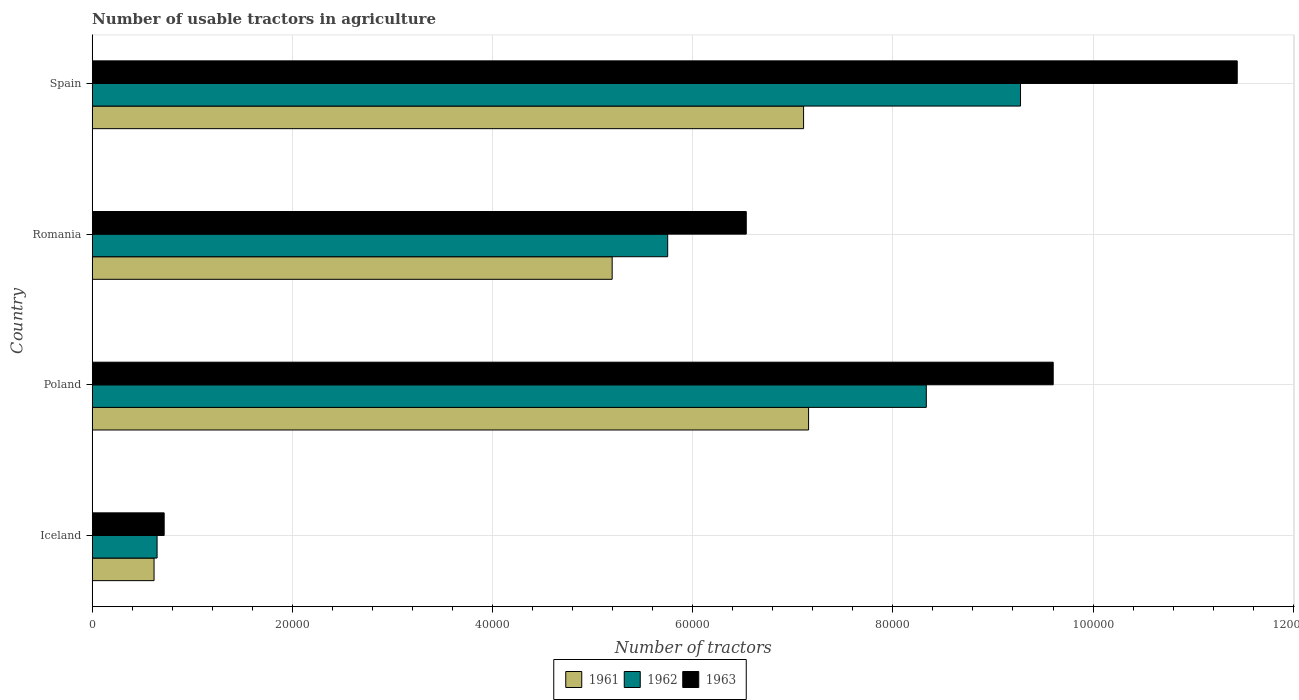How many groups of bars are there?
Keep it short and to the point. 4. Are the number of bars per tick equal to the number of legend labels?
Keep it short and to the point. Yes. What is the label of the 2nd group of bars from the top?
Ensure brevity in your answer.  Romania. What is the number of usable tractors in agriculture in 1961 in Poland?
Provide a short and direct response. 7.16e+04. Across all countries, what is the maximum number of usable tractors in agriculture in 1962?
Your answer should be very brief. 9.28e+04. Across all countries, what is the minimum number of usable tractors in agriculture in 1963?
Offer a terse response. 7187. In which country was the number of usable tractors in agriculture in 1962 minimum?
Offer a very short reply. Iceland. What is the total number of usable tractors in agriculture in 1962 in the graph?
Your answer should be compact. 2.40e+05. What is the difference between the number of usable tractors in agriculture in 1961 in Iceland and that in Spain?
Ensure brevity in your answer.  -6.49e+04. What is the difference between the number of usable tractors in agriculture in 1962 in Romania and the number of usable tractors in agriculture in 1963 in Spain?
Your answer should be very brief. -5.69e+04. What is the average number of usable tractors in agriculture in 1963 per country?
Ensure brevity in your answer.  7.07e+04. What is the difference between the number of usable tractors in agriculture in 1962 and number of usable tractors in agriculture in 1961 in Iceland?
Offer a very short reply. 302. What is the ratio of the number of usable tractors in agriculture in 1963 in Iceland to that in Romania?
Ensure brevity in your answer.  0.11. What is the difference between the highest and the lowest number of usable tractors in agriculture in 1963?
Your answer should be very brief. 1.07e+05. In how many countries, is the number of usable tractors in agriculture in 1961 greater than the average number of usable tractors in agriculture in 1961 taken over all countries?
Provide a short and direct response. 3. Is the sum of the number of usable tractors in agriculture in 1962 in Iceland and Spain greater than the maximum number of usable tractors in agriculture in 1963 across all countries?
Your answer should be compact. No. What does the 1st bar from the top in Romania represents?
Provide a succinct answer. 1963. Is it the case that in every country, the sum of the number of usable tractors in agriculture in 1963 and number of usable tractors in agriculture in 1962 is greater than the number of usable tractors in agriculture in 1961?
Your answer should be very brief. Yes. What is the difference between two consecutive major ticks on the X-axis?
Offer a very short reply. 2.00e+04. Are the values on the major ticks of X-axis written in scientific E-notation?
Your answer should be very brief. No. Does the graph contain grids?
Ensure brevity in your answer.  Yes. Where does the legend appear in the graph?
Offer a terse response. Bottom center. What is the title of the graph?
Offer a very short reply. Number of usable tractors in agriculture. What is the label or title of the X-axis?
Provide a succinct answer. Number of tractors. What is the Number of tractors in 1961 in Iceland?
Keep it short and to the point. 6177. What is the Number of tractors in 1962 in Iceland?
Ensure brevity in your answer.  6479. What is the Number of tractors in 1963 in Iceland?
Your answer should be very brief. 7187. What is the Number of tractors of 1961 in Poland?
Your answer should be compact. 7.16e+04. What is the Number of tractors in 1962 in Poland?
Give a very brief answer. 8.33e+04. What is the Number of tractors of 1963 in Poland?
Keep it short and to the point. 9.60e+04. What is the Number of tractors in 1961 in Romania?
Your answer should be compact. 5.20e+04. What is the Number of tractors of 1962 in Romania?
Keep it short and to the point. 5.75e+04. What is the Number of tractors of 1963 in Romania?
Your answer should be compact. 6.54e+04. What is the Number of tractors of 1961 in Spain?
Your response must be concise. 7.11e+04. What is the Number of tractors of 1962 in Spain?
Make the answer very short. 9.28e+04. What is the Number of tractors of 1963 in Spain?
Give a very brief answer. 1.14e+05. Across all countries, what is the maximum Number of tractors in 1961?
Offer a very short reply. 7.16e+04. Across all countries, what is the maximum Number of tractors in 1962?
Offer a very short reply. 9.28e+04. Across all countries, what is the maximum Number of tractors of 1963?
Ensure brevity in your answer.  1.14e+05. Across all countries, what is the minimum Number of tractors in 1961?
Keep it short and to the point. 6177. Across all countries, what is the minimum Number of tractors of 1962?
Offer a terse response. 6479. Across all countries, what is the minimum Number of tractors in 1963?
Provide a succinct answer. 7187. What is the total Number of tractors in 1961 in the graph?
Make the answer very short. 2.01e+05. What is the total Number of tractors of 1962 in the graph?
Ensure brevity in your answer.  2.40e+05. What is the total Number of tractors of 1963 in the graph?
Ensure brevity in your answer.  2.83e+05. What is the difference between the Number of tractors of 1961 in Iceland and that in Poland?
Provide a succinct answer. -6.54e+04. What is the difference between the Number of tractors of 1962 in Iceland and that in Poland?
Provide a succinct answer. -7.69e+04. What is the difference between the Number of tractors of 1963 in Iceland and that in Poland?
Offer a very short reply. -8.88e+04. What is the difference between the Number of tractors in 1961 in Iceland and that in Romania?
Make the answer very short. -4.58e+04. What is the difference between the Number of tractors in 1962 in Iceland and that in Romania?
Make the answer very short. -5.10e+04. What is the difference between the Number of tractors of 1963 in Iceland and that in Romania?
Keep it short and to the point. -5.82e+04. What is the difference between the Number of tractors in 1961 in Iceland and that in Spain?
Your answer should be very brief. -6.49e+04. What is the difference between the Number of tractors of 1962 in Iceland and that in Spain?
Your response must be concise. -8.63e+04. What is the difference between the Number of tractors of 1963 in Iceland and that in Spain?
Your response must be concise. -1.07e+05. What is the difference between the Number of tractors in 1961 in Poland and that in Romania?
Offer a very short reply. 1.96e+04. What is the difference between the Number of tractors in 1962 in Poland and that in Romania?
Provide a short and direct response. 2.58e+04. What is the difference between the Number of tractors in 1963 in Poland and that in Romania?
Ensure brevity in your answer.  3.07e+04. What is the difference between the Number of tractors of 1961 in Poland and that in Spain?
Provide a short and direct response. 500. What is the difference between the Number of tractors of 1962 in Poland and that in Spain?
Keep it short and to the point. -9414. What is the difference between the Number of tractors in 1963 in Poland and that in Spain?
Ensure brevity in your answer.  -1.84e+04. What is the difference between the Number of tractors in 1961 in Romania and that in Spain?
Offer a very short reply. -1.91e+04. What is the difference between the Number of tractors in 1962 in Romania and that in Spain?
Make the answer very short. -3.53e+04. What is the difference between the Number of tractors in 1963 in Romania and that in Spain?
Provide a succinct answer. -4.91e+04. What is the difference between the Number of tractors in 1961 in Iceland and the Number of tractors in 1962 in Poland?
Your response must be concise. -7.72e+04. What is the difference between the Number of tractors in 1961 in Iceland and the Number of tractors in 1963 in Poland?
Keep it short and to the point. -8.98e+04. What is the difference between the Number of tractors of 1962 in Iceland and the Number of tractors of 1963 in Poland?
Offer a very short reply. -8.95e+04. What is the difference between the Number of tractors in 1961 in Iceland and the Number of tractors in 1962 in Romania?
Your response must be concise. -5.13e+04. What is the difference between the Number of tractors in 1961 in Iceland and the Number of tractors in 1963 in Romania?
Make the answer very short. -5.92e+04. What is the difference between the Number of tractors in 1962 in Iceland and the Number of tractors in 1963 in Romania?
Give a very brief answer. -5.89e+04. What is the difference between the Number of tractors of 1961 in Iceland and the Number of tractors of 1962 in Spain?
Make the answer very short. -8.66e+04. What is the difference between the Number of tractors of 1961 in Iceland and the Number of tractors of 1963 in Spain?
Your answer should be compact. -1.08e+05. What is the difference between the Number of tractors in 1962 in Iceland and the Number of tractors in 1963 in Spain?
Your answer should be very brief. -1.08e+05. What is the difference between the Number of tractors in 1961 in Poland and the Number of tractors in 1962 in Romania?
Offer a very short reply. 1.41e+04. What is the difference between the Number of tractors in 1961 in Poland and the Number of tractors in 1963 in Romania?
Your response must be concise. 6226. What is the difference between the Number of tractors of 1962 in Poland and the Number of tractors of 1963 in Romania?
Offer a terse response. 1.80e+04. What is the difference between the Number of tractors in 1961 in Poland and the Number of tractors in 1962 in Spain?
Give a very brief answer. -2.12e+04. What is the difference between the Number of tractors in 1961 in Poland and the Number of tractors in 1963 in Spain?
Provide a short and direct response. -4.28e+04. What is the difference between the Number of tractors in 1962 in Poland and the Number of tractors in 1963 in Spain?
Offer a terse response. -3.11e+04. What is the difference between the Number of tractors of 1961 in Romania and the Number of tractors of 1962 in Spain?
Offer a terse response. -4.08e+04. What is the difference between the Number of tractors of 1961 in Romania and the Number of tractors of 1963 in Spain?
Your answer should be very brief. -6.25e+04. What is the difference between the Number of tractors in 1962 in Romania and the Number of tractors in 1963 in Spain?
Offer a terse response. -5.69e+04. What is the average Number of tractors in 1961 per country?
Your response must be concise. 5.02e+04. What is the average Number of tractors in 1962 per country?
Your response must be concise. 6.00e+04. What is the average Number of tractors in 1963 per country?
Offer a terse response. 7.07e+04. What is the difference between the Number of tractors in 1961 and Number of tractors in 1962 in Iceland?
Offer a terse response. -302. What is the difference between the Number of tractors of 1961 and Number of tractors of 1963 in Iceland?
Keep it short and to the point. -1010. What is the difference between the Number of tractors of 1962 and Number of tractors of 1963 in Iceland?
Give a very brief answer. -708. What is the difference between the Number of tractors of 1961 and Number of tractors of 1962 in Poland?
Your response must be concise. -1.18e+04. What is the difference between the Number of tractors of 1961 and Number of tractors of 1963 in Poland?
Give a very brief answer. -2.44e+04. What is the difference between the Number of tractors in 1962 and Number of tractors in 1963 in Poland?
Provide a succinct answer. -1.27e+04. What is the difference between the Number of tractors of 1961 and Number of tractors of 1962 in Romania?
Make the answer very short. -5548. What is the difference between the Number of tractors in 1961 and Number of tractors in 1963 in Romania?
Your answer should be very brief. -1.34e+04. What is the difference between the Number of tractors in 1962 and Number of tractors in 1963 in Romania?
Your answer should be compact. -7851. What is the difference between the Number of tractors of 1961 and Number of tractors of 1962 in Spain?
Provide a succinct answer. -2.17e+04. What is the difference between the Number of tractors of 1961 and Number of tractors of 1963 in Spain?
Keep it short and to the point. -4.33e+04. What is the difference between the Number of tractors of 1962 and Number of tractors of 1963 in Spain?
Your answer should be compact. -2.17e+04. What is the ratio of the Number of tractors of 1961 in Iceland to that in Poland?
Ensure brevity in your answer.  0.09. What is the ratio of the Number of tractors in 1962 in Iceland to that in Poland?
Provide a short and direct response. 0.08. What is the ratio of the Number of tractors of 1963 in Iceland to that in Poland?
Ensure brevity in your answer.  0.07. What is the ratio of the Number of tractors of 1961 in Iceland to that in Romania?
Offer a very short reply. 0.12. What is the ratio of the Number of tractors of 1962 in Iceland to that in Romania?
Provide a short and direct response. 0.11. What is the ratio of the Number of tractors in 1963 in Iceland to that in Romania?
Offer a terse response. 0.11. What is the ratio of the Number of tractors of 1961 in Iceland to that in Spain?
Keep it short and to the point. 0.09. What is the ratio of the Number of tractors of 1962 in Iceland to that in Spain?
Provide a short and direct response. 0.07. What is the ratio of the Number of tractors of 1963 in Iceland to that in Spain?
Keep it short and to the point. 0.06. What is the ratio of the Number of tractors in 1961 in Poland to that in Romania?
Make the answer very short. 1.38. What is the ratio of the Number of tractors in 1962 in Poland to that in Romania?
Your answer should be very brief. 1.45. What is the ratio of the Number of tractors in 1963 in Poland to that in Romania?
Give a very brief answer. 1.47. What is the ratio of the Number of tractors of 1961 in Poland to that in Spain?
Make the answer very short. 1.01. What is the ratio of the Number of tractors of 1962 in Poland to that in Spain?
Provide a short and direct response. 0.9. What is the ratio of the Number of tractors of 1963 in Poland to that in Spain?
Offer a very short reply. 0.84. What is the ratio of the Number of tractors of 1961 in Romania to that in Spain?
Offer a very short reply. 0.73. What is the ratio of the Number of tractors in 1962 in Romania to that in Spain?
Keep it short and to the point. 0.62. What is the ratio of the Number of tractors in 1963 in Romania to that in Spain?
Offer a terse response. 0.57. What is the difference between the highest and the second highest Number of tractors in 1962?
Provide a succinct answer. 9414. What is the difference between the highest and the second highest Number of tractors of 1963?
Ensure brevity in your answer.  1.84e+04. What is the difference between the highest and the lowest Number of tractors in 1961?
Your answer should be compact. 6.54e+04. What is the difference between the highest and the lowest Number of tractors of 1962?
Keep it short and to the point. 8.63e+04. What is the difference between the highest and the lowest Number of tractors of 1963?
Provide a short and direct response. 1.07e+05. 